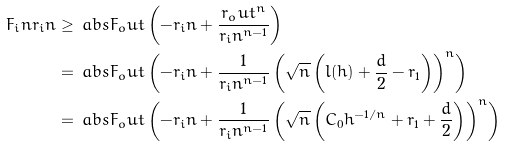Convert formula to latex. <formula><loc_0><loc_0><loc_500><loc_500>F _ { i } n r _ { i } n \geq \, & \ a b s { F _ { o } u t } \left ( - r _ { i } n + \frac { r _ { o } u t ^ { n } } { r _ { i } n ^ { n - 1 } } \right ) \\ = \, & \ a b s { F _ { o } u t } \left ( - r _ { i } n + \frac { 1 } { r _ { i } n ^ { n - 1 } } \left ( \sqrt { n } \left ( l ( h ) + \frac { d } { 2 } - r _ { 1 } \right ) \right ) ^ { n } \right ) \\ = \, & \ a b s { F _ { o } u t } \left ( - r _ { i } n + \frac { 1 } { r _ { i } n ^ { n - 1 } } \left ( \sqrt { n } \left ( C _ { 0 } h ^ { - 1 / n } + r _ { 1 } + \frac { d } { 2 } \right ) \right ) ^ { n } \right )</formula> 